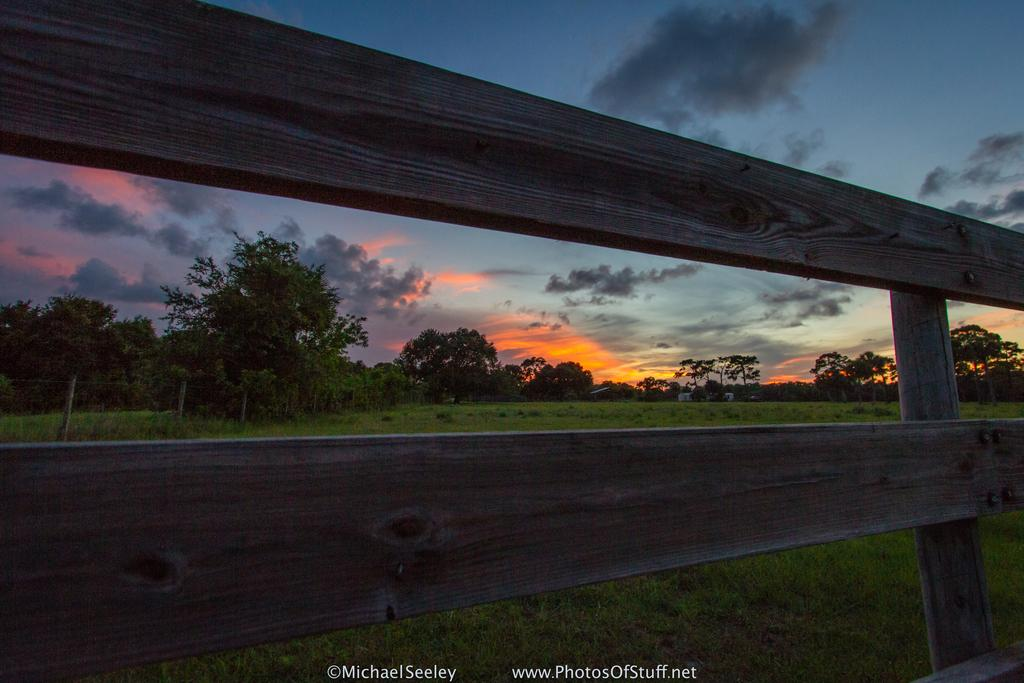What type of structure can be seen in the image? There is a fencing in the image. What type of vegetation is present in the image? There are trees and grass in the image. What is the condition of the sky in the image? The sky is cloudy in the image. How many chickens can be seen in the image? There are no chickens present in the image. What type of lead is used for the fencing in the image? There is: There is no mention of the material used for the fencing in the image, but it appears to be made of metal. 